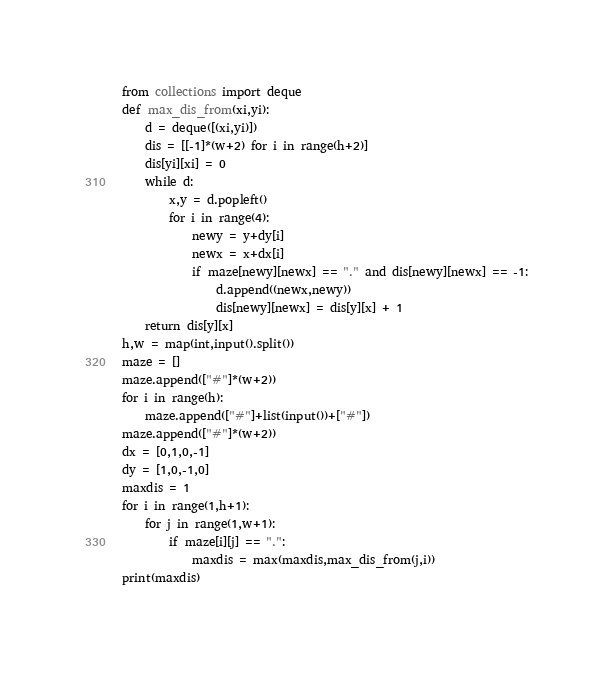Convert code to text. <code><loc_0><loc_0><loc_500><loc_500><_Python_>from collections import deque
def max_dis_from(xi,yi):
    d = deque([(xi,yi)])
    dis = [[-1]*(w+2) for i in range(h+2)]
    dis[yi][xi] = 0
    while d:
        x,y = d.popleft()
        for i in range(4):
            newy = y+dy[i]
            newx = x+dx[i]
            if maze[newy][newx] == "." and dis[newy][newx] == -1:
                d.append((newx,newy))
                dis[newy][newx] = dis[y][x] + 1
    return dis[y][x]   
h,w = map(int,input().split())
maze = []
maze.append(["#"]*(w+2))
for i in range(h):
    maze.append(["#"]+list(input())+["#"])
maze.append(["#"]*(w+2))
dx = [0,1,0,-1]
dy = [1,0,-1,0]
maxdis = 1
for i in range(1,h+1):
    for j in range(1,w+1):
        if maze[i][j] == ".":
            maxdis = max(maxdis,max_dis_from(j,i))
print(maxdis)</code> 